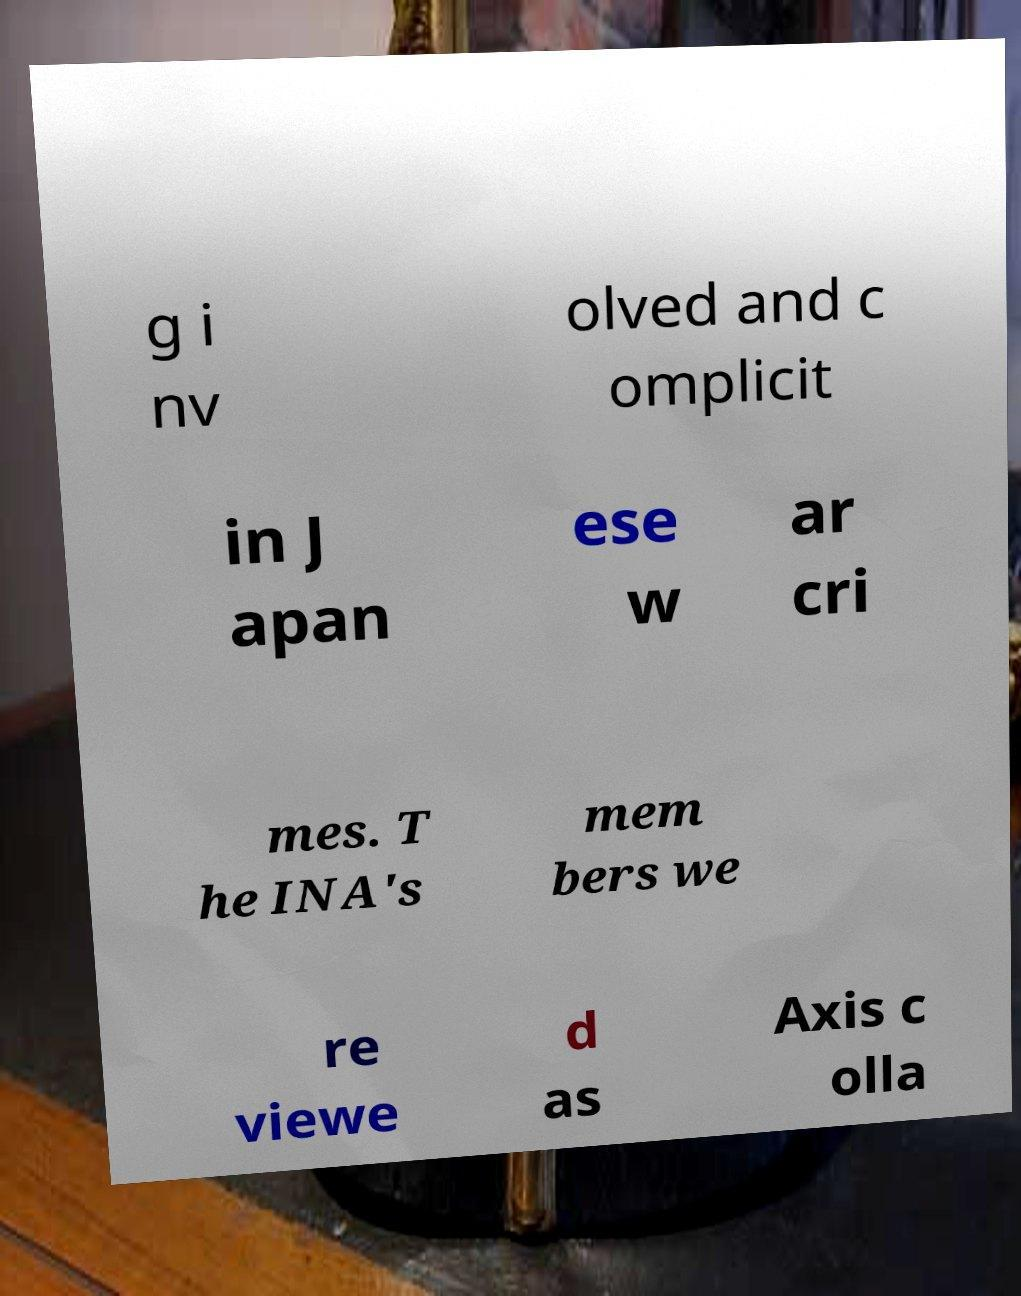Could you extract and type out the text from this image? g i nv olved and c omplicit in J apan ese w ar cri mes. T he INA's mem bers we re viewe d as Axis c olla 